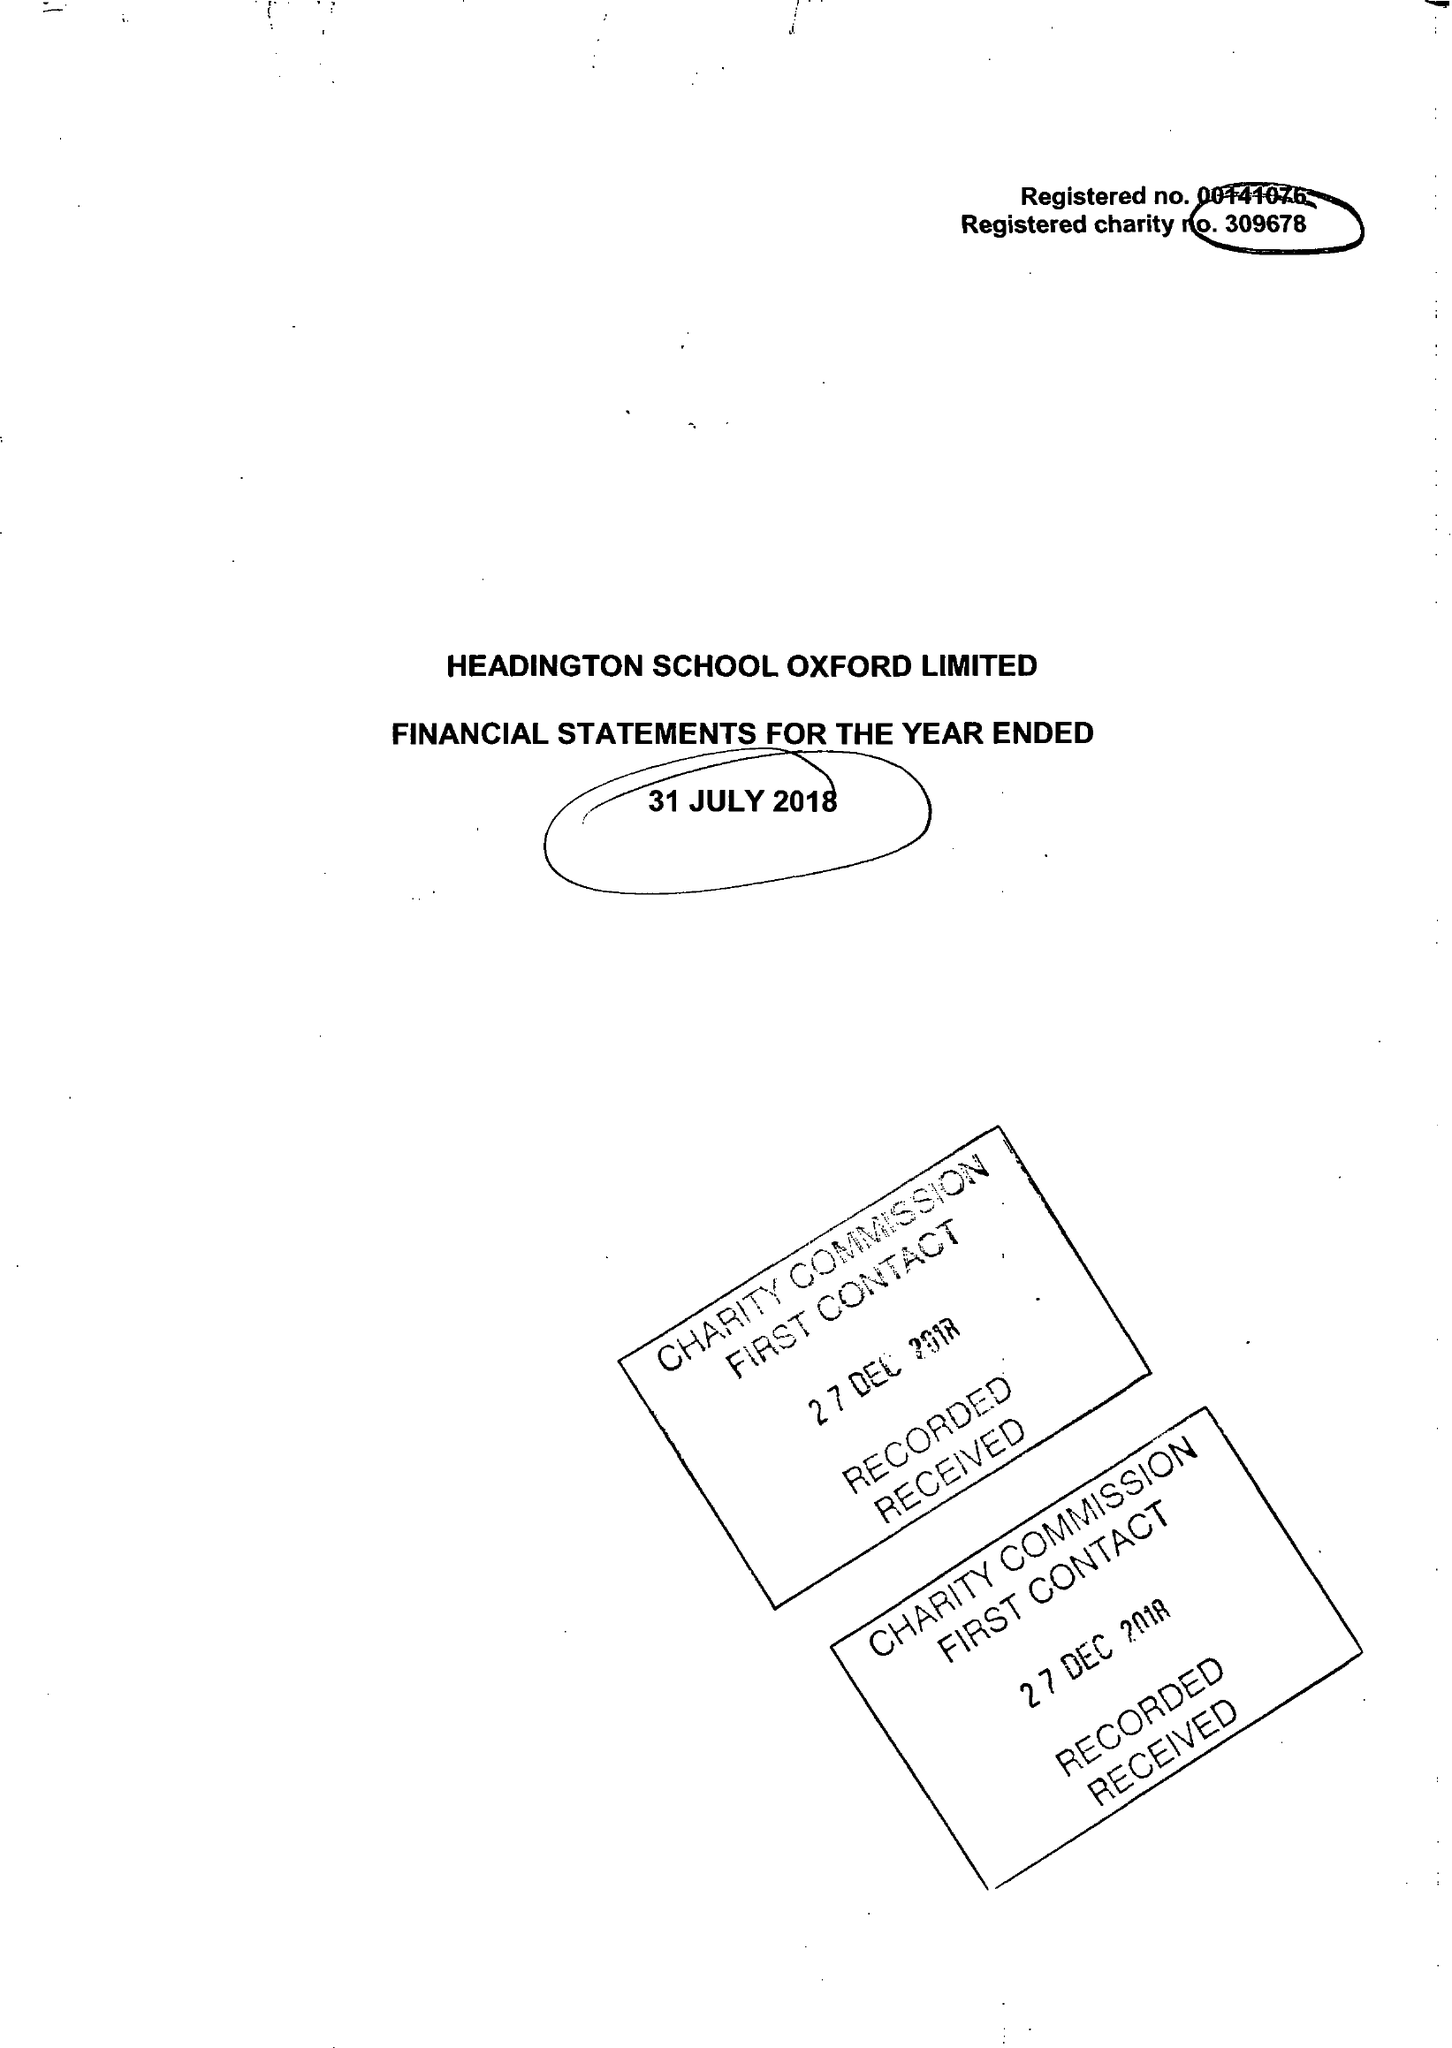What is the value for the address__postcode?
Answer the question using a single word or phrase. OX3 0BL 